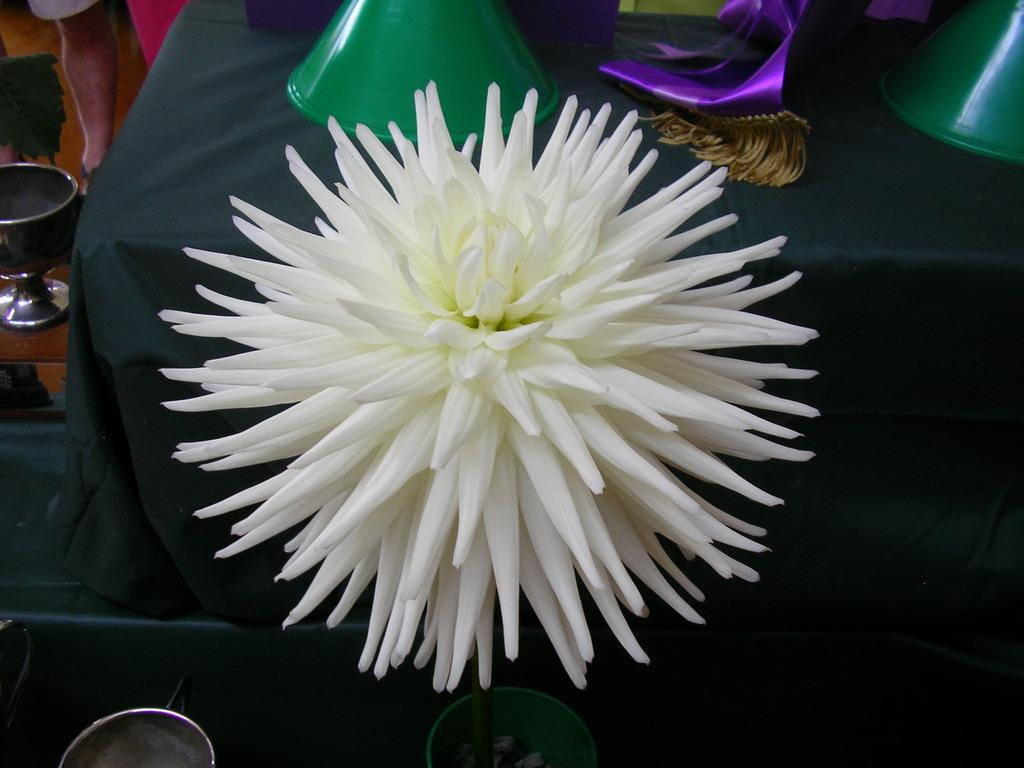What is the main subject in the middle of the image? There is a flower in the middle of the image. What else can be seen in the image besides the flower? There are plastic things on a table in the image. Reasoning: Let's think step by identifying the main subject and other objects in the image. We start by mentioning the flower, which is the primary focus of the image. Then, we acknowledge the presence of plastic things on a table, providing additional context about the scene. We avoid yes/no questions and ensure that the language is simple and clear. Absurd Question/Answer: What type of lawyer is sitting in the van in the image? There is no van or lawyer present in the image. How many flowers are being sorted in the image? There is only one flower visible in the image, and it is not being sorted. 